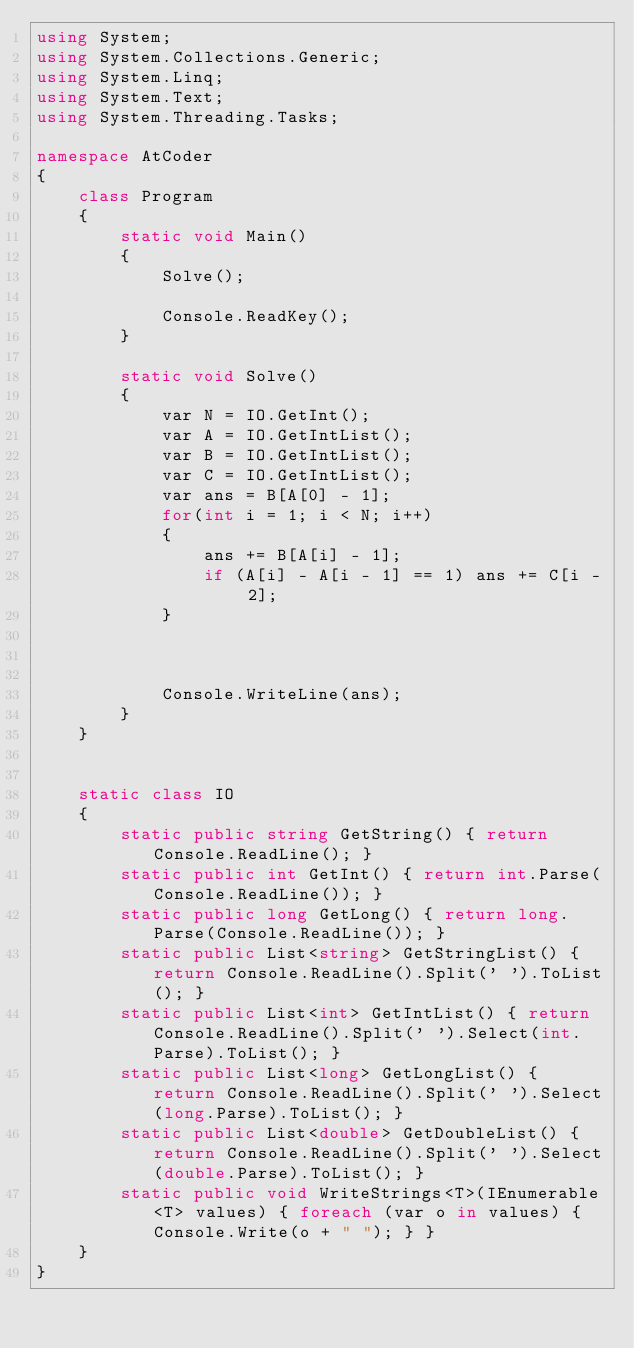Convert code to text. <code><loc_0><loc_0><loc_500><loc_500><_C#_>using System;
using System.Collections.Generic;
using System.Linq;
using System.Text;
using System.Threading.Tasks;

namespace AtCoder
{
    class Program
    {
        static void Main()
        {
            Solve();

            Console.ReadKey();
        }

        static void Solve()
        {
            var N = IO.GetInt();
            var A = IO.GetIntList();
            var B = IO.GetIntList();
            var C = IO.GetIntList();
            var ans = B[A[0] - 1];
            for(int i = 1; i < N; i++)
            {
                ans += B[A[i] - 1];
                if (A[i] - A[i - 1] == 1) ans += C[i - 2];
            }

            

            Console.WriteLine(ans);
        }
    }


    static class IO
    {
        static public string GetString() { return Console.ReadLine(); }
        static public int GetInt() { return int.Parse(Console.ReadLine()); }
        static public long GetLong() { return long.Parse(Console.ReadLine()); }
        static public List<string> GetStringList() { return Console.ReadLine().Split(' ').ToList(); }
        static public List<int> GetIntList() { return Console.ReadLine().Split(' ').Select(int.Parse).ToList(); }
        static public List<long> GetLongList() { return Console.ReadLine().Split(' ').Select(long.Parse).ToList(); }
        static public List<double> GetDoubleList() { return Console.ReadLine().Split(' ').Select(double.Parse).ToList(); }
        static public void WriteStrings<T>(IEnumerable<T> values) { foreach (var o in values) { Console.Write(o + " "); } }
    }
}</code> 